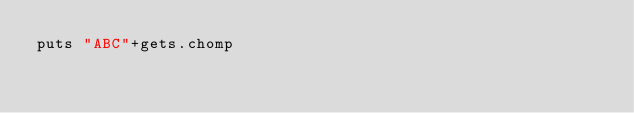<code> <loc_0><loc_0><loc_500><loc_500><_Ruby_>puts "ABC"+gets.chomp</code> 